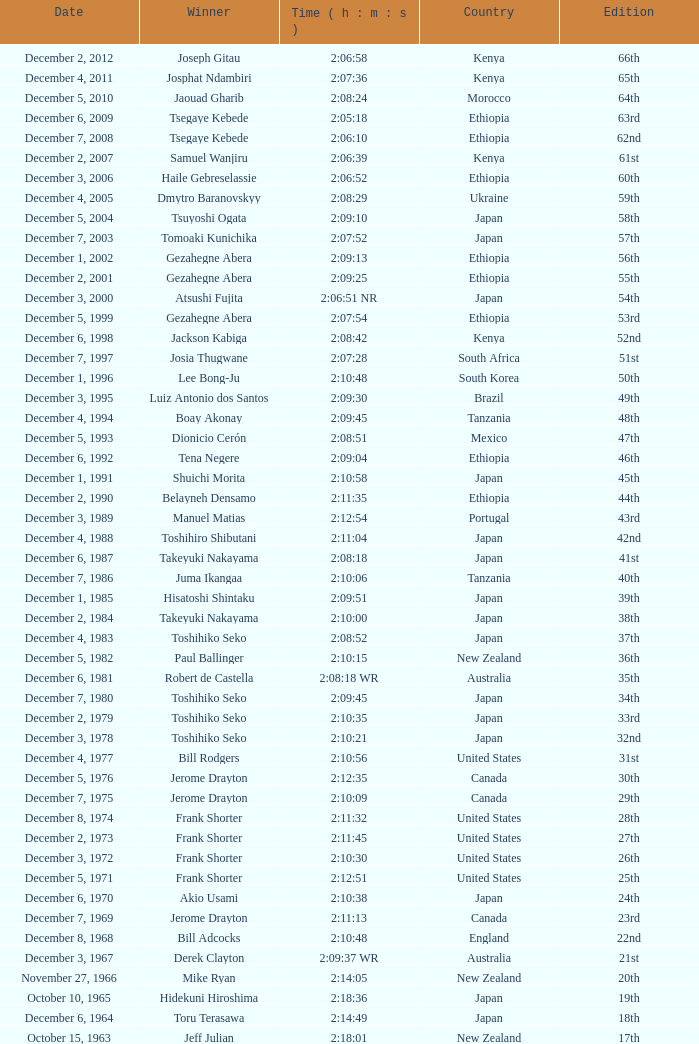What was the nationality of the winner for the 20th Edition? New Zealand. 